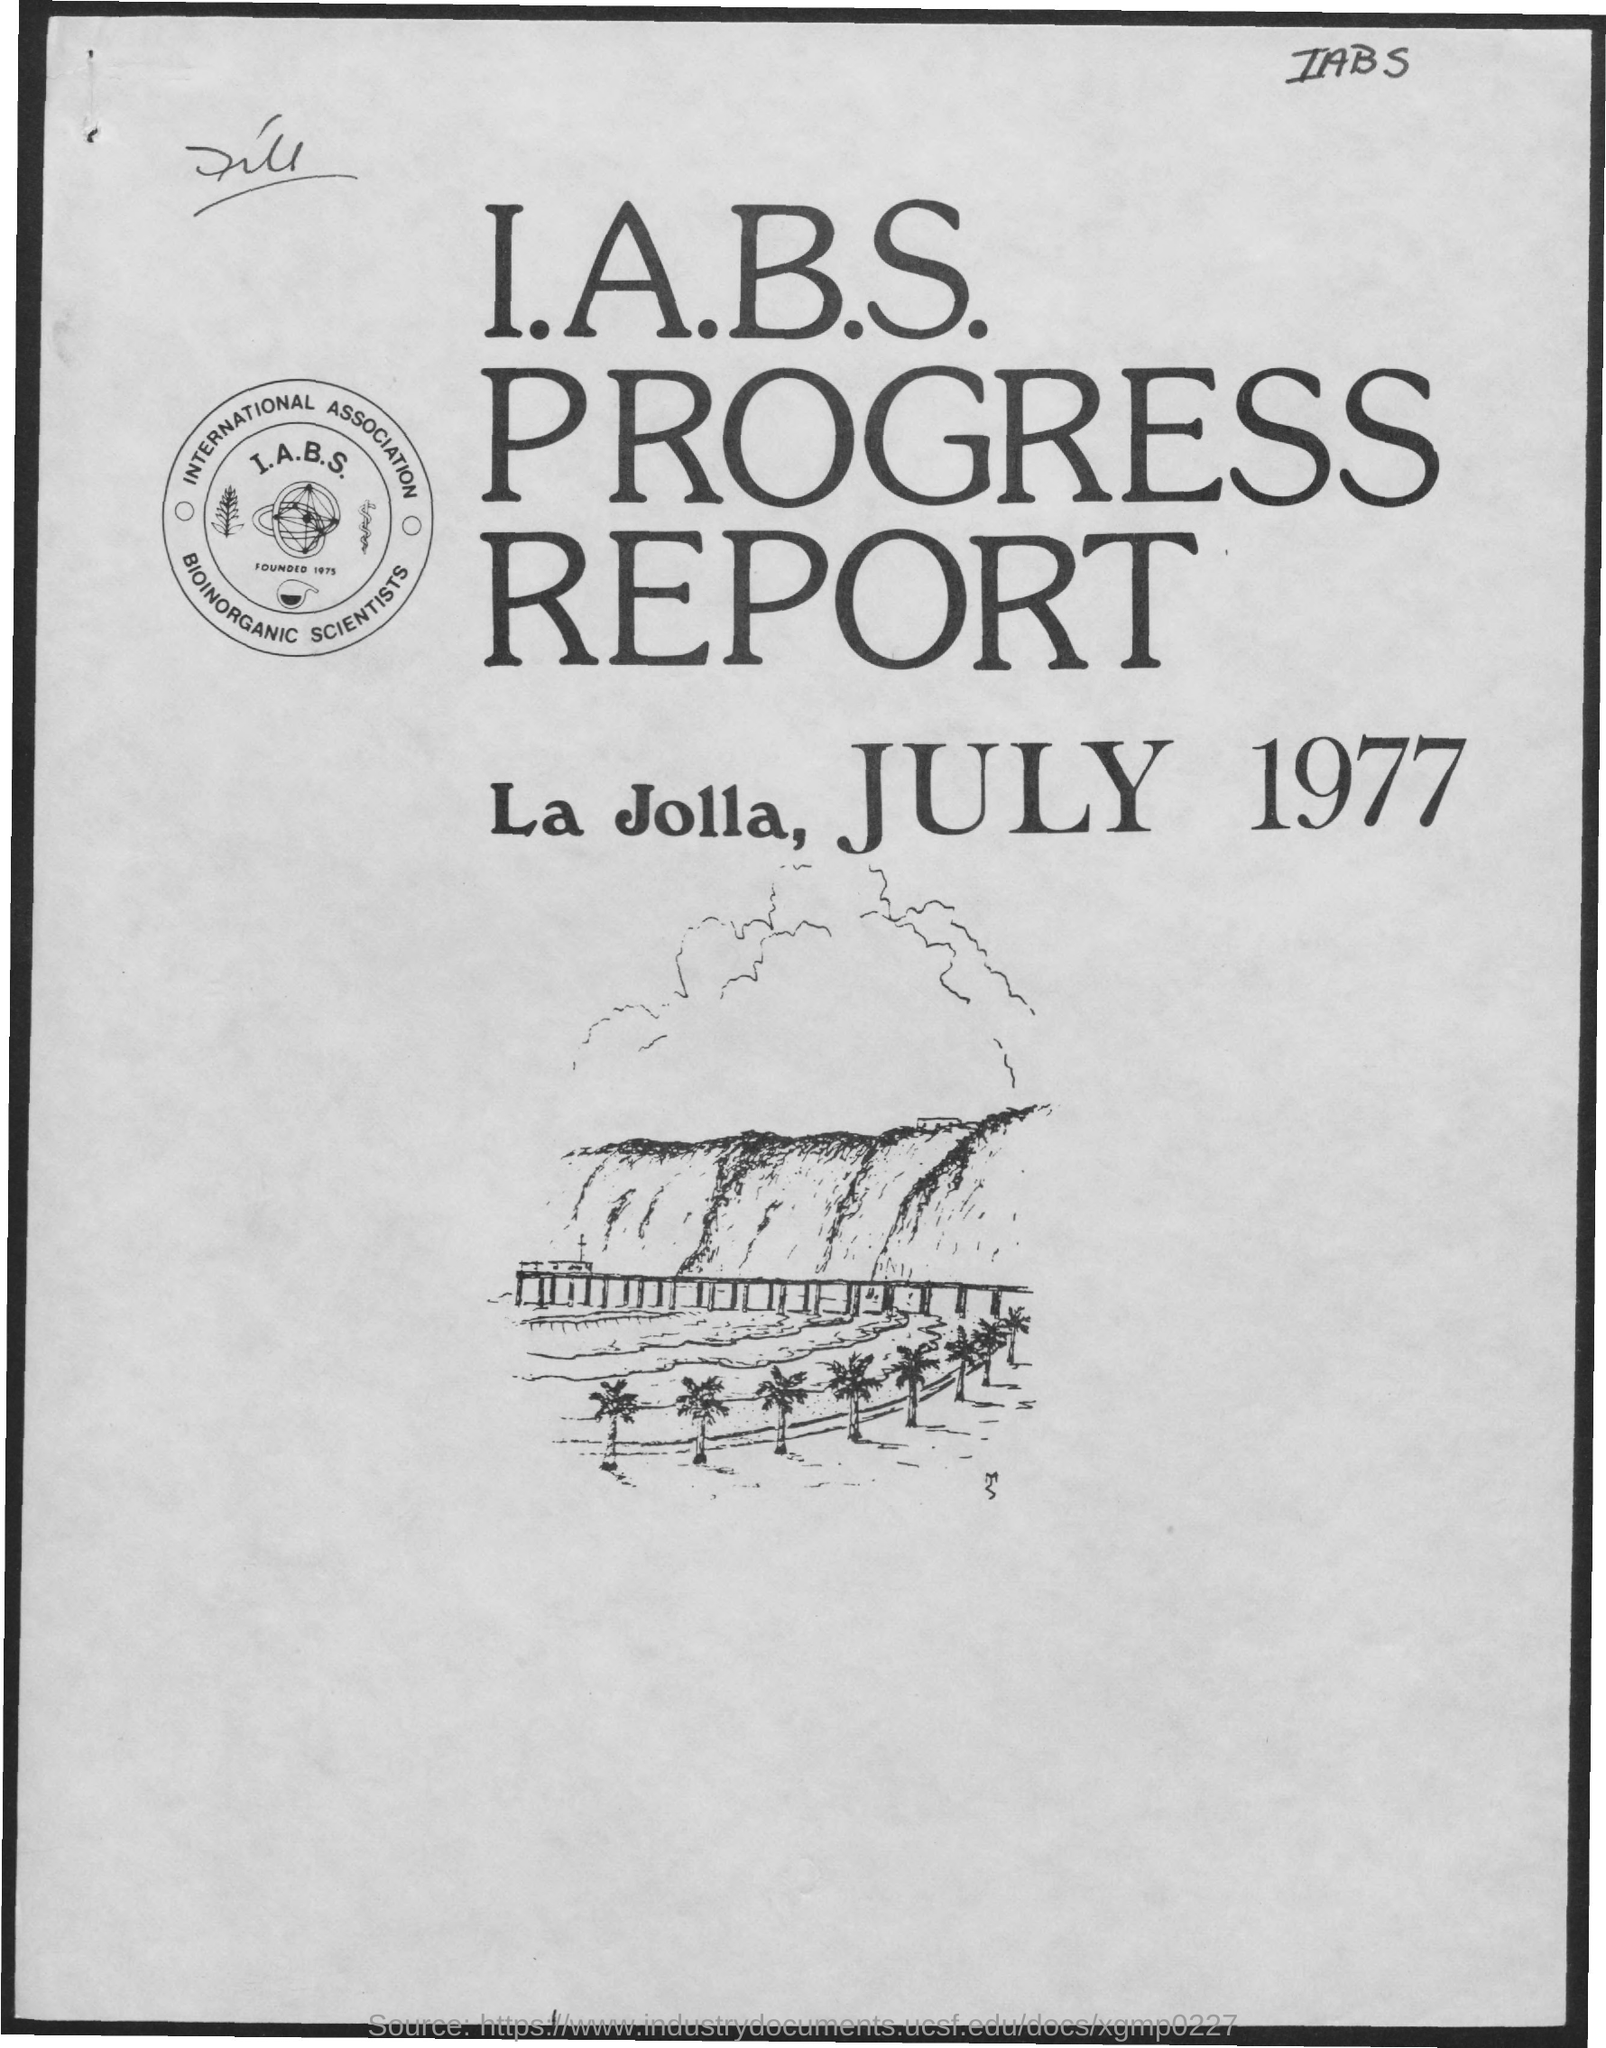What is the name of the report?
Provide a succinct answer. I.A.B.S progress report. What is the place of report?
Give a very brief answer. La Jolla. What is the date of issue of report?
Offer a terse response. July 1977. What is month mentioned in the page?
Your answer should be compact. July. 